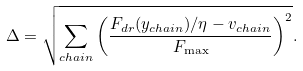<formula> <loc_0><loc_0><loc_500><loc_500>\Delta = \sqrt { \sum _ { c h a i n } \left ( \frac { F _ { d r } ( y _ { c h a i n } ) / \eta - v _ { c h a i n } } { F _ { \max } } \right ) ^ { 2 } } .</formula> 